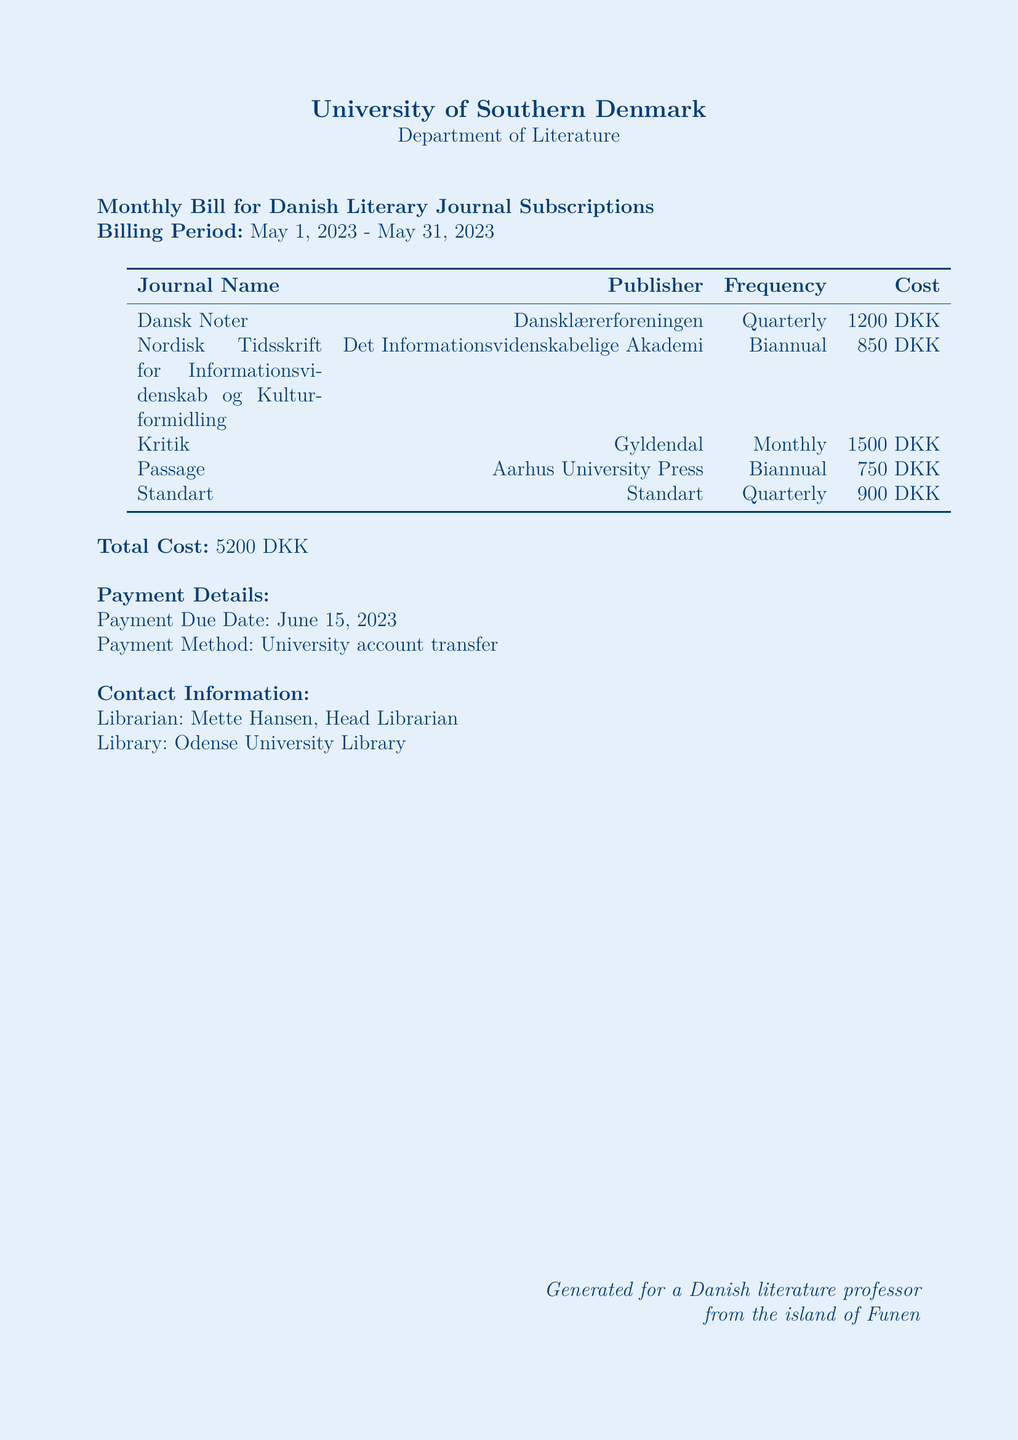what is the total cost of the subscriptions? The total cost is explicitly stated at the end of the document as the sum of all journal costs which amounts to 5200 DKK.
Answer: 5200 DKK who is the head librarian? The document mentions the head librarian's name in the contact information section, which is Mette Hansen.
Answer: Mette Hansen what is the billing period? The billing period is specified at the beginning of the document, covering May 1, 2023 to May 31, 2023.
Answer: May 1, 2023 - May 31, 2023 how often is the journal "Kritik" published? The document specifies the frequency of publication for each journal, noting that "Kritik" is published monthly.
Answer: Monthly what is the payment due date? The payment details section provides the due date for the payment, which is June 15, 2023.
Answer: June 15, 2023 which organization publishes "Passage"? The document lists the publisher for each journal, showing that "Passage" is published by Aarhus University Press.
Answer: Aarhus University Press how much does "Nordisk Tidsskrift for Informationsvidenskab og Kulturformidling" cost? The cost for each journal is detailed in the table, specifically stating that this journal costs 850 DKK.
Answer: 850 DKK what is the payment method indicated? The payment method is mentioned in the payment details section, stating that it is through a university account transfer.
Answer: University account transfer which journal has the highest cost? By comparing the costs listed in the table, it is evident that "Kritik" has the highest cost at 1500 DKK.
Answer: Kritik 